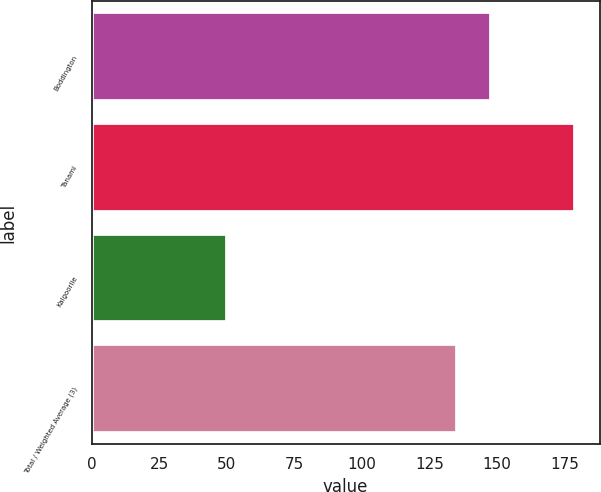Convert chart. <chart><loc_0><loc_0><loc_500><loc_500><bar_chart><fcel>Boddington<fcel>Tanami<fcel>Kalgoorlie<fcel>Total / Weighted Average (3)<nl><fcel>147.9<fcel>179<fcel>50<fcel>135<nl></chart> 